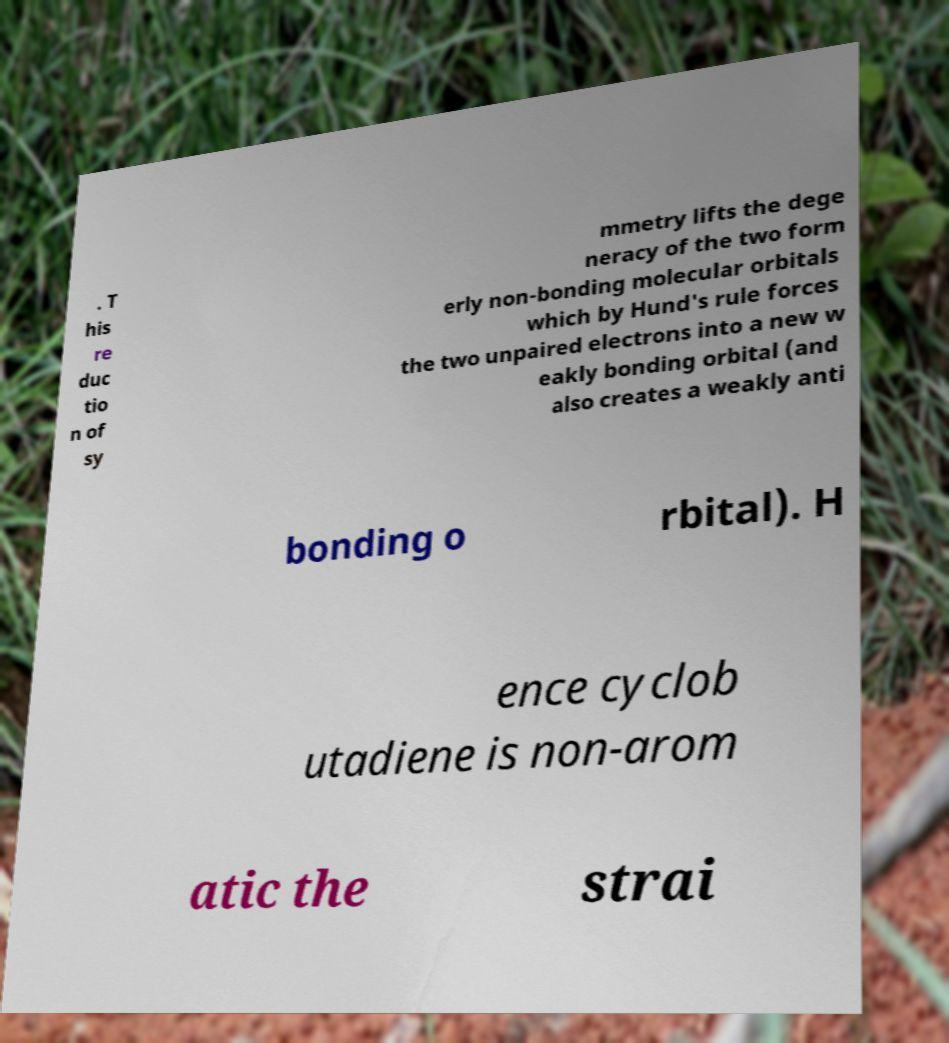For documentation purposes, I need the text within this image transcribed. Could you provide that? . T his re duc tio n of sy mmetry lifts the dege neracy of the two form erly non-bonding molecular orbitals which by Hund's rule forces the two unpaired electrons into a new w eakly bonding orbital (and also creates a weakly anti bonding o rbital). H ence cyclob utadiene is non-arom atic the strai 